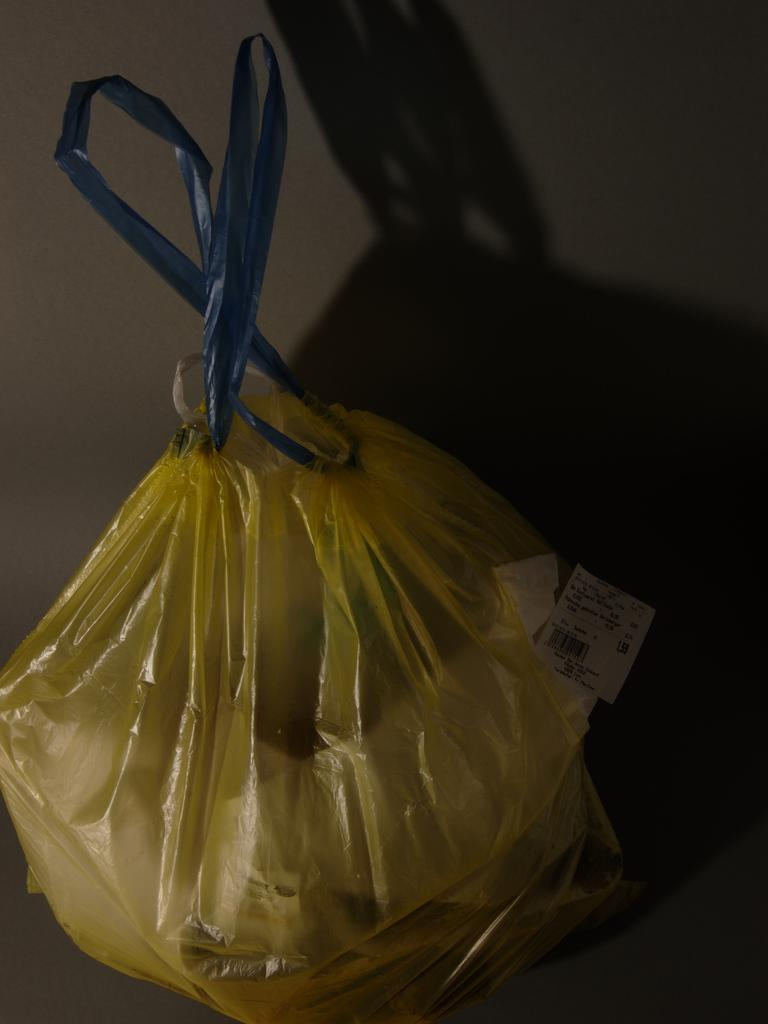What object is covered by the plastic cover in the image? The facts provided do not specify what object is covered by the plastic cover. Where is the plastic cover located in the image? The plastic cover is placed on a table in the image. What can be seen in the background of the image? There is a shadow of the cover and a wall in the background of the image. What type of ring can be seen on the cushion in the image? There is no ring or cushion present in the image; it only features a plastic cover on a table and a background with a shadow and a wall. 